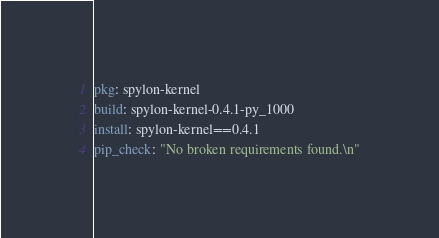Convert code to text. <code><loc_0><loc_0><loc_500><loc_500><_YAML_>pkg: spylon-kernel
build: spylon-kernel-0.4.1-py_1000
install: spylon-kernel==0.4.1
pip_check: "No broken requirements found.\n"
</code> 